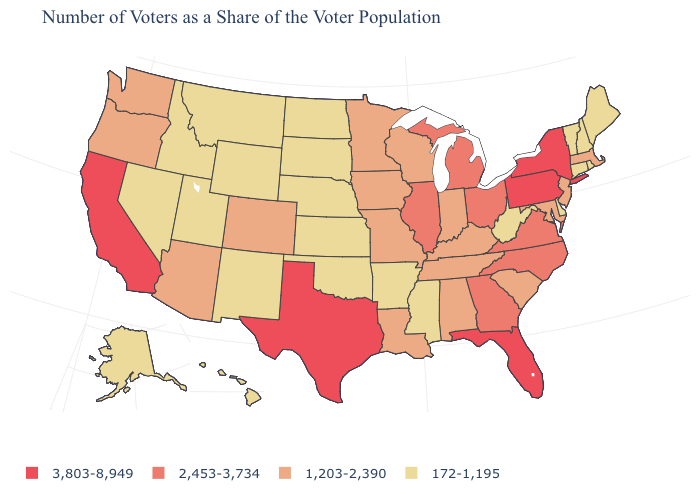What is the highest value in states that border Tennessee?
Answer briefly. 2,453-3,734. Which states have the lowest value in the USA?
Keep it brief. Alaska, Arkansas, Connecticut, Delaware, Hawaii, Idaho, Kansas, Maine, Mississippi, Montana, Nebraska, Nevada, New Hampshire, New Mexico, North Dakota, Oklahoma, Rhode Island, South Dakota, Utah, Vermont, West Virginia, Wyoming. Name the states that have a value in the range 3,803-8,949?
Be succinct. California, Florida, New York, Pennsylvania, Texas. What is the highest value in the USA?
Write a very short answer. 3,803-8,949. Which states have the highest value in the USA?
Give a very brief answer. California, Florida, New York, Pennsylvania, Texas. How many symbols are there in the legend?
Give a very brief answer. 4. Among the states that border Connecticut , which have the lowest value?
Answer briefly. Rhode Island. What is the highest value in the USA?
Write a very short answer. 3,803-8,949. Does the first symbol in the legend represent the smallest category?
Concise answer only. No. What is the lowest value in the USA?
Short answer required. 172-1,195. Which states hav the highest value in the South?
Short answer required. Florida, Texas. Which states hav the highest value in the MidWest?
Be succinct. Illinois, Michigan, Ohio. What is the value of Alabama?
Be succinct. 1,203-2,390. What is the value of Massachusetts?
Quick response, please. 1,203-2,390. What is the highest value in the USA?
Answer briefly. 3,803-8,949. 